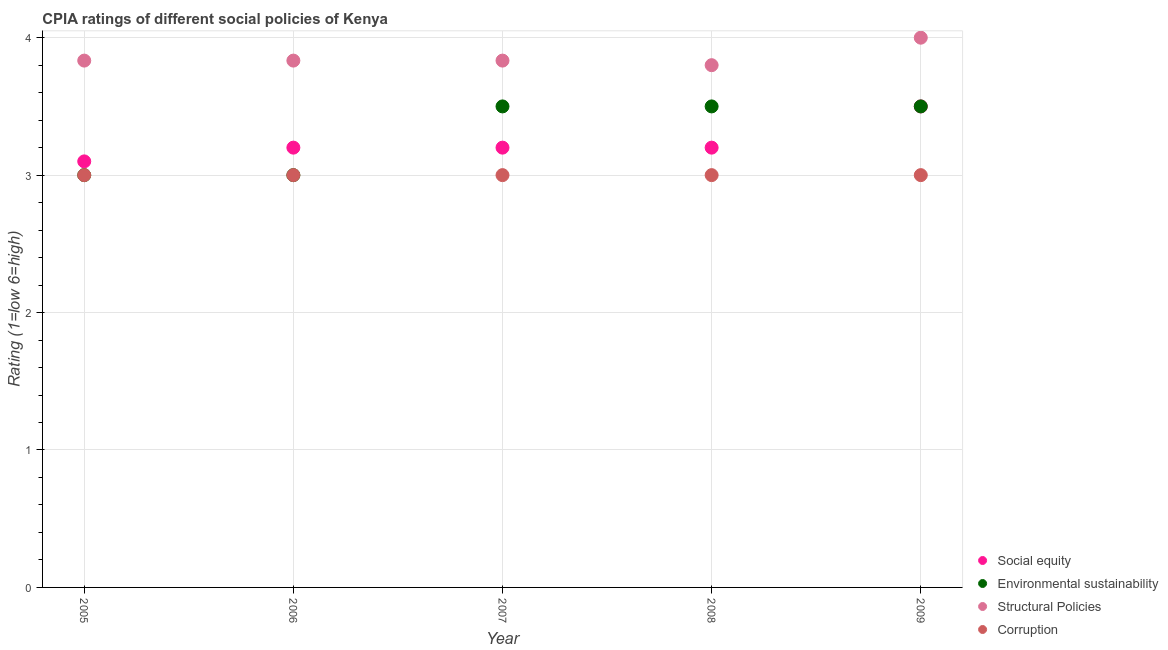How many different coloured dotlines are there?
Ensure brevity in your answer.  4. Is the number of dotlines equal to the number of legend labels?
Provide a short and direct response. Yes. Across all years, what is the maximum cpia rating of corruption?
Your answer should be compact. 3. What is the total cpia rating of social equity in the graph?
Your answer should be very brief. 16.2. What is the difference between the cpia rating of social equity in 2008 and that in 2009?
Your response must be concise. -0.3. What is the difference between the cpia rating of social equity in 2008 and the cpia rating of corruption in 2009?
Offer a very short reply. 0.2. What is the average cpia rating of corruption per year?
Offer a terse response. 3. In the year 2008, what is the difference between the cpia rating of environmental sustainability and cpia rating of social equity?
Offer a very short reply. 0.3. In how many years, is the cpia rating of environmental sustainability greater than 3.2?
Provide a short and direct response. 3. What is the ratio of the cpia rating of corruption in 2005 to that in 2009?
Offer a terse response. 1. Is the cpia rating of corruption in 2005 less than that in 2008?
Give a very brief answer. No. Is the difference between the cpia rating of social equity in 2005 and 2008 greater than the difference between the cpia rating of structural policies in 2005 and 2008?
Provide a short and direct response. No. What is the difference between the highest and the second highest cpia rating of corruption?
Your answer should be compact. 0. What is the difference between the highest and the lowest cpia rating of structural policies?
Keep it short and to the point. 0.2. In how many years, is the cpia rating of corruption greater than the average cpia rating of corruption taken over all years?
Offer a terse response. 0. Is the sum of the cpia rating of corruption in 2007 and 2008 greater than the maximum cpia rating of social equity across all years?
Your response must be concise. Yes. Is it the case that in every year, the sum of the cpia rating of structural policies and cpia rating of environmental sustainability is greater than the sum of cpia rating of corruption and cpia rating of social equity?
Provide a succinct answer. No. Is it the case that in every year, the sum of the cpia rating of social equity and cpia rating of environmental sustainability is greater than the cpia rating of structural policies?
Your answer should be compact. Yes. Is the cpia rating of environmental sustainability strictly greater than the cpia rating of social equity over the years?
Give a very brief answer. No. Is the cpia rating of corruption strictly less than the cpia rating of environmental sustainability over the years?
Offer a terse response. No. What is the difference between two consecutive major ticks on the Y-axis?
Your response must be concise. 1. How are the legend labels stacked?
Offer a terse response. Vertical. What is the title of the graph?
Your answer should be very brief. CPIA ratings of different social policies of Kenya. Does "Ease of arranging shipments" appear as one of the legend labels in the graph?
Your answer should be very brief. No. What is the label or title of the X-axis?
Keep it short and to the point. Year. What is the Rating (1=low 6=high) in Environmental sustainability in 2005?
Your answer should be compact. 3. What is the Rating (1=low 6=high) of Structural Policies in 2005?
Offer a terse response. 3.83. What is the Rating (1=low 6=high) of Social equity in 2006?
Ensure brevity in your answer.  3.2. What is the Rating (1=low 6=high) in Structural Policies in 2006?
Your answer should be compact. 3.83. What is the Rating (1=low 6=high) in Corruption in 2006?
Keep it short and to the point. 3. What is the Rating (1=low 6=high) of Environmental sustainability in 2007?
Keep it short and to the point. 3.5. What is the Rating (1=low 6=high) in Structural Policies in 2007?
Your response must be concise. 3.83. What is the Rating (1=low 6=high) of Environmental sustainability in 2008?
Provide a short and direct response. 3.5. What is the Rating (1=low 6=high) in Structural Policies in 2008?
Give a very brief answer. 3.8. What is the Rating (1=low 6=high) in Corruption in 2008?
Provide a short and direct response. 3. What is the Rating (1=low 6=high) of Social equity in 2009?
Provide a short and direct response. 3.5. What is the Rating (1=low 6=high) in Structural Policies in 2009?
Offer a very short reply. 4. Across all years, what is the maximum Rating (1=low 6=high) in Social equity?
Make the answer very short. 3.5. Across all years, what is the maximum Rating (1=low 6=high) of Environmental sustainability?
Make the answer very short. 3.5. Across all years, what is the maximum Rating (1=low 6=high) in Structural Policies?
Your answer should be compact. 4. Across all years, what is the maximum Rating (1=low 6=high) in Corruption?
Offer a terse response. 3. Across all years, what is the minimum Rating (1=low 6=high) in Structural Policies?
Your answer should be compact. 3.8. Across all years, what is the minimum Rating (1=low 6=high) in Corruption?
Offer a terse response. 3. What is the total Rating (1=low 6=high) of Social equity in the graph?
Provide a succinct answer. 16.2. What is the total Rating (1=low 6=high) in Environmental sustainability in the graph?
Keep it short and to the point. 16.5. What is the total Rating (1=low 6=high) in Structural Policies in the graph?
Ensure brevity in your answer.  19.3. What is the difference between the Rating (1=low 6=high) of Structural Policies in 2005 and that in 2006?
Your response must be concise. 0. What is the difference between the Rating (1=low 6=high) of Corruption in 2005 and that in 2006?
Provide a succinct answer. 0. What is the difference between the Rating (1=low 6=high) in Social equity in 2005 and that in 2007?
Keep it short and to the point. -0.1. What is the difference between the Rating (1=low 6=high) of Structural Policies in 2005 and that in 2007?
Make the answer very short. 0. What is the difference between the Rating (1=low 6=high) in Environmental sustainability in 2005 and that in 2008?
Ensure brevity in your answer.  -0.5. What is the difference between the Rating (1=low 6=high) in Structural Policies in 2005 and that in 2008?
Provide a succinct answer. 0.03. What is the difference between the Rating (1=low 6=high) of Corruption in 2005 and that in 2008?
Make the answer very short. 0. What is the difference between the Rating (1=low 6=high) in Structural Policies in 2005 and that in 2009?
Make the answer very short. -0.17. What is the difference between the Rating (1=low 6=high) of Corruption in 2005 and that in 2009?
Ensure brevity in your answer.  0. What is the difference between the Rating (1=low 6=high) in Social equity in 2006 and that in 2009?
Provide a succinct answer. -0.3. What is the difference between the Rating (1=low 6=high) of Environmental sustainability in 2006 and that in 2009?
Offer a very short reply. -0.5. What is the difference between the Rating (1=low 6=high) in Structural Policies in 2006 and that in 2009?
Make the answer very short. -0.17. What is the difference between the Rating (1=low 6=high) of Social equity in 2007 and that in 2008?
Provide a short and direct response. 0. What is the difference between the Rating (1=low 6=high) of Environmental sustainability in 2007 and that in 2008?
Your answer should be very brief. 0. What is the difference between the Rating (1=low 6=high) of Social equity in 2007 and that in 2009?
Provide a short and direct response. -0.3. What is the difference between the Rating (1=low 6=high) in Environmental sustainability in 2007 and that in 2009?
Offer a terse response. 0. What is the difference between the Rating (1=low 6=high) in Social equity in 2008 and that in 2009?
Offer a very short reply. -0.3. What is the difference between the Rating (1=low 6=high) of Environmental sustainability in 2008 and that in 2009?
Make the answer very short. 0. What is the difference between the Rating (1=low 6=high) in Social equity in 2005 and the Rating (1=low 6=high) in Environmental sustainability in 2006?
Give a very brief answer. 0.1. What is the difference between the Rating (1=low 6=high) of Social equity in 2005 and the Rating (1=low 6=high) of Structural Policies in 2006?
Make the answer very short. -0.73. What is the difference between the Rating (1=low 6=high) in Social equity in 2005 and the Rating (1=low 6=high) in Corruption in 2006?
Provide a succinct answer. 0.1. What is the difference between the Rating (1=low 6=high) of Environmental sustainability in 2005 and the Rating (1=low 6=high) of Corruption in 2006?
Ensure brevity in your answer.  0. What is the difference between the Rating (1=low 6=high) in Social equity in 2005 and the Rating (1=low 6=high) in Structural Policies in 2007?
Make the answer very short. -0.73. What is the difference between the Rating (1=low 6=high) of Environmental sustainability in 2005 and the Rating (1=low 6=high) of Structural Policies in 2007?
Provide a succinct answer. -0.83. What is the difference between the Rating (1=low 6=high) in Structural Policies in 2005 and the Rating (1=low 6=high) in Corruption in 2007?
Offer a terse response. 0.83. What is the difference between the Rating (1=low 6=high) of Social equity in 2005 and the Rating (1=low 6=high) of Environmental sustainability in 2008?
Make the answer very short. -0.4. What is the difference between the Rating (1=low 6=high) of Social equity in 2005 and the Rating (1=low 6=high) of Structural Policies in 2008?
Your response must be concise. -0.7. What is the difference between the Rating (1=low 6=high) in Social equity in 2005 and the Rating (1=low 6=high) in Corruption in 2008?
Keep it short and to the point. 0.1. What is the difference between the Rating (1=low 6=high) in Environmental sustainability in 2005 and the Rating (1=low 6=high) in Structural Policies in 2008?
Offer a very short reply. -0.8. What is the difference between the Rating (1=low 6=high) of Social equity in 2005 and the Rating (1=low 6=high) of Structural Policies in 2009?
Give a very brief answer. -0.9. What is the difference between the Rating (1=low 6=high) of Environmental sustainability in 2005 and the Rating (1=low 6=high) of Structural Policies in 2009?
Offer a very short reply. -1. What is the difference between the Rating (1=low 6=high) of Structural Policies in 2005 and the Rating (1=low 6=high) of Corruption in 2009?
Your response must be concise. 0.83. What is the difference between the Rating (1=low 6=high) in Social equity in 2006 and the Rating (1=low 6=high) in Structural Policies in 2007?
Ensure brevity in your answer.  -0.63. What is the difference between the Rating (1=low 6=high) of Social equity in 2006 and the Rating (1=low 6=high) of Corruption in 2007?
Give a very brief answer. 0.2. What is the difference between the Rating (1=low 6=high) in Environmental sustainability in 2006 and the Rating (1=low 6=high) in Corruption in 2007?
Provide a short and direct response. 0. What is the difference between the Rating (1=low 6=high) of Social equity in 2006 and the Rating (1=low 6=high) of Structural Policies in 2008?
Your response must be concise. -0.6. What is the difference between the Rating (1=low 6=high) of Environmental sustainability in 2006 and the Rating (1=low 6=high) of Structural Policies in 2009?
Make the answer very short. -1. What is the difference between the Rating (1=low 6=high) in Social equity in 2007 and the Rating (1=low 6=high) in Environmental sustainability in 2008?
Your answer should be compact. -0.3. What is the difference between the Rating (1=low 6=high) of Environmental sustainability in 2007 and the Rating (1=low 6=high) of Corruption in 2008?
Give a very brief answer. 0.5. What is the difference between the Rating (1=low 6=high) of Social equity in 2007 and the Rating (1=low 6=high) of Environmental sustainability in 2009?
Offer a terse response. -0.3. What is the difference between the Rating (1=low 6=high) of Social equity in 2007 and the Rating (1=low 6=high) of Structural Policies in 2009?
Keep it short and to the point. -0.8. What is the difference between the Rating (1=low 6=high) of Social equity in 2007 and the Rating (1=low 6=high) of Corruption in 2009?
Offer a terse response. 0.2. What is the difference between the Rating (1=low 6=high) in Structural Policies in 2007 and the Rating (1=low 6=high) in Corruption in 2009?
Offer a terse response. 0.83. What is the difference between the Rating (1=low 6=high) of Social equity in 2008 and the Rating (1=low 6=high) of Structural Policies in 2009?
Keep it short and to the point. -0.8. What is the difference between the Rating (1=low 6=high) of Social equity in 2008 and the Rating (1=low 6=high) of Corruption in 2009?
Your answer should be very brief. 0.2. What is the difference between the Rating (1=low 6=high) in Environmental sustainability in 2008 and the Rating (1=low 6=high) in Structural Policies in 2009?
Give a very brief answer. -0.5. What is the difference between the Rating (1=low 6=high) in Environmental sustainability in 2008 and the Rating (1=low 6=high) in Corruption in 2009?
Your response must be concise. 0.5. What is the average Rating (1=low 6=high) in Social equity per year?
Ensure brevity in your answer.  3.24. What is the average Rating (1=low 6=high) of Structural Policies per year?
Your answer should be very brief. 3.86. In the year 2005, what is the difference between the Rating (1=low 6=high) of Social equity and Rating (1=low 6=high) of Environmental sustainability?
Offer a terse response. 0.1. In the year 2005, what is the difference between the Rating (1=low 6=high) of Social equity and Rating (1=low 6=high) of Structural Policies?
Provide a succinct answer. -0.73. In the year 2005, what is the difference between the Rating (1=low 6=high) in Social equity and Rating (1=low 6=high) in Corruption?
Give a very brief answer. 0.1. In the year 2005, what is the difference between the Rating (1=low 6=high) in Environmental sustainability and Rating (1=low 6=high) in Structural Policies?
Give a very brief answer. -0.83. In the year 2005, what is the difference between the Rating (1=low 6=high) of Structural Policies and Rating (1=low 6=high) of Corruption?
Make the answer very short. 0.83. In the year 2006, what is the difference between the Rating (1=low 6=high) of Social equity and Rating (1=low 6=high) of Structural Policies?
Ensure brevity in your answer.  -0.63. In the year 2006, what is the difference between the Rating (1=low 6=high) of Social equity and Rating (1=low 6=high) of Corruption?
Your response must be concise. 0.2. In the year 2006, what is the difference between the Rating (1=low 6=high) in Environmental sustainability and Rating (1=low 6=high) in Structural Policies?
Provide a short and direct response. -0.83. In the year 2007, what is the difference between the Rating (1=low 6=high) of Social equity and Rating (1=low 6=high) of Structural Policies?
Your response must be concise. -0.63. In the year 2007, what is the difference between the Rating (1=low 6=high) of Environmental sustainability and Rating (1=low 6=high) of Structural Policies?
Your response must be concise. -0.33. In the year 2007, what is the difference between the Rating (1=low 6=high) of Structural Policies and Rating (1=low 6=high) of Corruption?
Your answer should be very brief. 0.83. In the year 2008, what is the difference between the Rating (1=low 6=high) of Social equity and Rating (1=low 6=high) of Environmental sustainability?
Give a very brief answer. -0.3. In the year 2008, what is the difference between the Rating (1=low 6=high) in Social equity and Rating (1=low 6=high) in Structural Policies?
Give a very brief answer. -0.6. In the year 2008, what is the difference between the Rating (1=low 6=high) of Environmental sustainability and Rating (1=low 6=high) of Structural Policies?
Your answer should be very brief. -0.3. In the year 2008, what is the difference between the Rating (1=low 6=high) in Structural Policies and Rating (1=low 6=high) in Corruption?
Offer a terse response. 0.8. In the year 2009, what is the difference between the Rating (1=low 6=high) of Social equity and Rating (1=low 6=high) of Structural Policies?
Your answer should be compact. -0.5. In the year 2009, what is the difference between the Rating (1=low 6=high) in Structural Policies and Rating (1=low 6=high) in Corruption?
Ensure brevity in your answer.  1. What is the ratio of the Rating (1=low 6=high) in Social equity in 2005 to that in 2006?
Offer a very short reply. 0.97. What is the ratio of the Rating (1=low 6=high) of Environmental sustainability in 2005 to that in 2006?
Provide a succinct answer. 1. What is the ratio of the Rating (1=low 6=high) in Corruption in 2005 to that in 2006?
Keep it short and to the point. 1. What is the ratio of the Rating (1=low 6=high) of Social equity in 2005 to that in 2007?
Your answer should be very brief. 0.97. What is the ratio of the Rating (1=low 6=high) of Structural Policies in 2005 to that in 2007?
Give a very brief answer. 1. What is the ratio of the Rating (1=low 6=high) in Social equity in 2005 to that in 2008?
Your answer should be compact. 0.97. What is the ratio of the Rating (1=low 6=high) in Structural Policies in 2005 to that in 2008?
Your response must be concise. 1.01. What is the ratio of the Rating (1=low 6=high) in Corruption in 2005 to that in 2008?
Your response must be concise. 1. What is the ratio of the Rating (1=low 6=high) of Social equity in 2005 to that in 2009?
Your response must be concise. 0.89. What is the ratio of the Rating (1=low 6=high) of Structural Policies in 2005 to that in 2009?
Give a very brief answer. 0.96. What is the ratio of the Rating (1=low 6=high) in Environmental sustainability in 2006 to that in 2007?
Make the answer very short. 0.86. What is the ratio of the Rating (1=low 6=high) in Structural Policies in 2006 to that in 2007?
Your response must be concise. 1. What is the ratio of the Rating (1=low 6=high) of Corruption in 2006 to that in 2007?
Offer a terse response. 1. What is the ratio of the Rating (1=low 6=high) in Social equity in 2006 to that in 2008?
Give a very brief answer. 1. What is the ratio of the Rating (1=low 6=high) in Environmental sustainability in 2006 to that in 2008?
Provide a succinct answer. 0.86. What is the ratio of the Rating (1=low 6=high) of Structural Policies in 2006 to that in 2008?
Provide a succinct answer. 1.01. What is the ratio of the Rating (1=low 6=high) in Corruption in 2006 to that in 2008?
Provide a succinct answer. 1. What is the ratio of the Rating (1=low 6=high) in Social equity in 2006 to that in 2009?
Keep it short and to the point. 0.91. What is the ratio of the Rating (1=low 6=high) in Social equity in 2007 to that in 2008?
Your response must be concise. 1. What is the ratio of the Rating (1=low 6=high) of Structural Policies in 2007 to that in 2008?
Give a very brief answer. 1.01. What is the ratio of the Rating (1=low 6=high) of Corruption in 2007 to that in 2008?
Keep it short and to the point. 1. What is the ratio of the Rating (1=low 6=high) in Social equity in 2007 to that in 2009?
Give a very brief answer. 0.91. What is the ratio of the Rating (1=low 6=high) of Environmental sustainability in 2007 to that in 2009?
Make the answer very short. 1. What is the ratio of the Rating (1=low 6=high) of Structural Policies in 2007 to that in 2009?
Ensure brevity in your answer.  0.96. What is the ratio of the Rating (1=low 6=high) in Social equity in 2008 to that in 2009?
Give a very brief answer. 0.91. What is the ratio of the Rating (1=low 6=high) of Structural Policies in 2008 to that in 2009?
Your response must be concise. 0.95. What is the difference between the highest and the second highest Rating (1=low 6=high) in Structural Policies?
Your answer should be very brief. 0.17. What is the difference between the highest and the lowest Rating (1=low 6=high) of Environmental sustainability?
Provide a short and direct response. 0.5. 